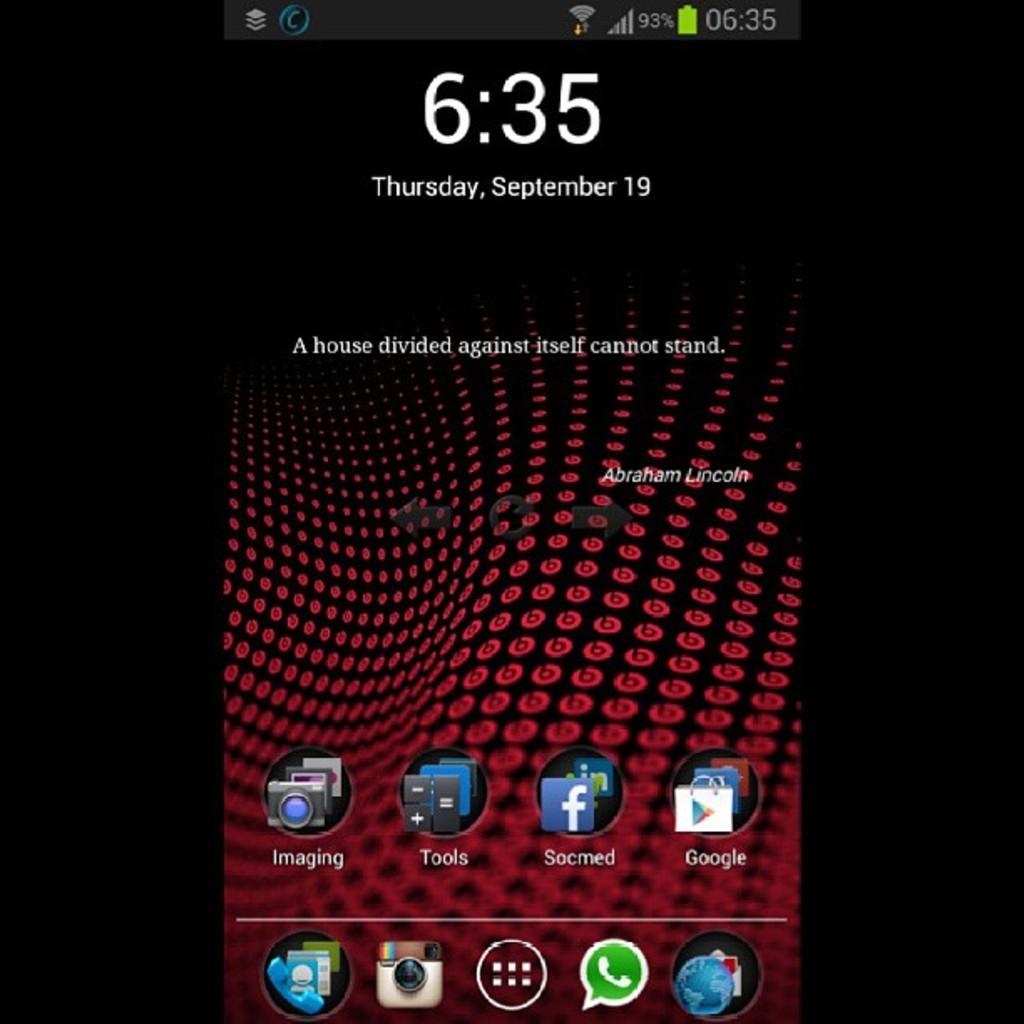What time is it?
Offer a terse response. 6:35. What is the date?
Your response must be concise. September 19. 